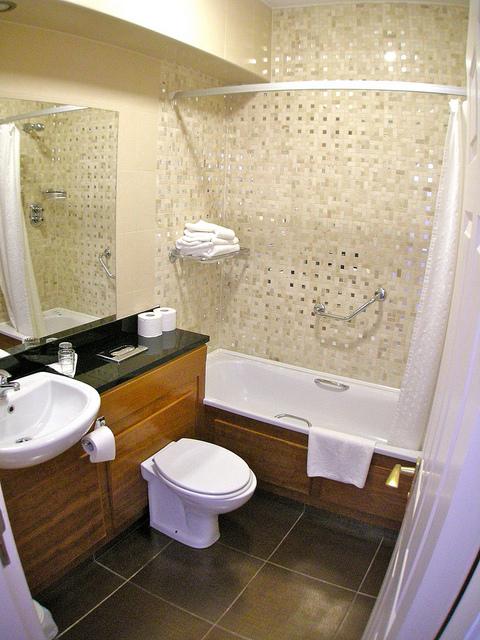Is the shower curtain open or shut?
Short answer required. Open. How many tiles?
Quick response, please. 10. How many rolls of toilet paper are next to the sink?
Keep it brief. 2. Is the toilet seat open?
Write a very short answer. No. 